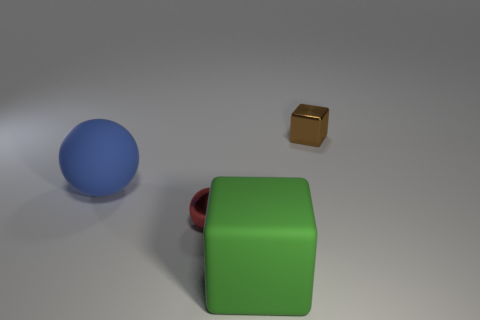Is there anything else that is the same size as the green rubber object?
Keep it short and to the point. Yes. Does the tiny shiny object to the left of the brown shiny thing have the same shape as the small shiny thing right of the metal ball?
Give a very brief answer. No. Is the number of big blue things that are in front of the big ball greater than the number of green metal balls?
Make the answer very short. No. How many objects are metal spheres or brown objects?
Offer a very short reply. 2. What is the color of the metallic block?
Your answer should be very brief. Brown. How many other things are there of the same color as the big sphere?
Ensure brevity in your answer.  0. There is a rubber block; are there any large matte balls in front of it?
Your answer should be very brief. No. There is a big object to the right of the red sphere in front of the brown metal object behind the blue sphere; what is its color?
Your answer should be very brief. Green. What number of things are both on the right side of the large green object and in front of the tiny red sphere?
Give a very brief answer. 0. What number of cubes are either green objects or rubber things?
Your answer should be compact. 1. 